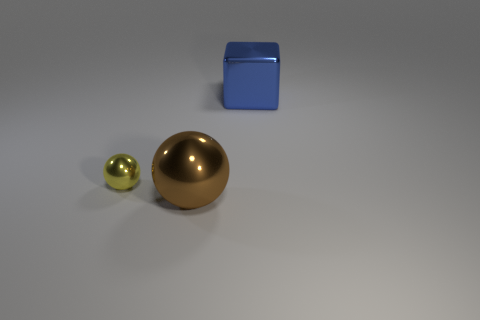Is there anything else that is the same shape as the blue thing?
Offer a terse response. No. What is the shape of the metallic thing that is on the left side of the blue metallic cube and to the right of the yellow shiny object?
Offer a terse response. Sphere. Is there anything else that has the same size as the yellow metal object?
Your answer should be compact. No. What is the color of the large thing that is on the right side of the big thing to the left of the cube?
Your answer should be compact. Blue. What shape is the large thing that is behind the big shiny object to the left of the large shiny thing that is behind the tiny yellow sphere?
Make the answer very short. Cube. There is a metallic object that is both in front of the large blue shiny object and behind the large brown sphere; what is its size?
Your answer should be very brief. Small. There is a big thing that is in front of the blue block; what is its shape?
Your response must be concise. Sphere. What material is the sphere that is the same size as the block?
Keep it short and to the point. Metal. How many objects are big objects that are to the left of the blue shiny object or shiny objects that are to the left of the shiny cube?
Offer a very short reply. 2. What size is the yellow sphere that is made of the same material as the big brown sphere?
Offer a terse response. Small. 